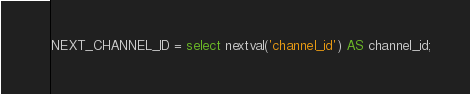Convert code to text. <code><loc_0><loc_0><loc_500><loc_500><_SQL_>NEXT_CHANNEL_ID = select nextval('channel_id') AS channel_id;</code> 